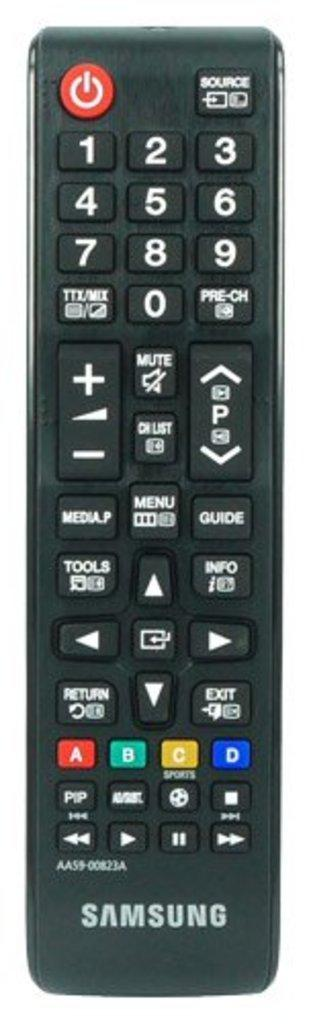Provide a one-sentence caption for the provided image. The long black remote control is labeled Samsung. 